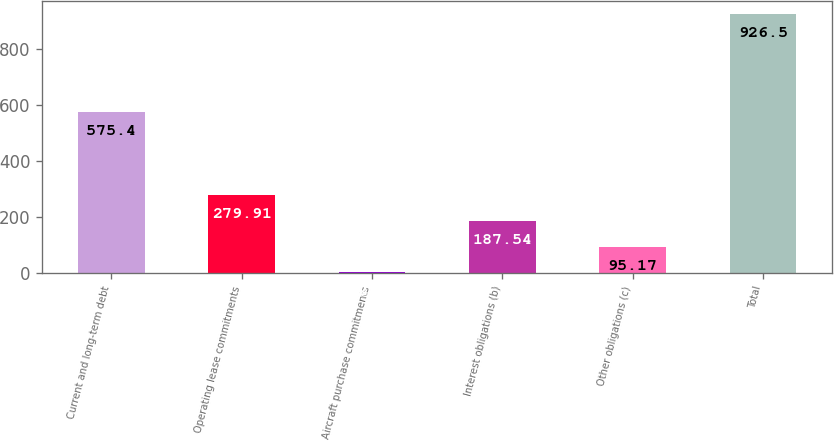Convert chart. <chart><loc_0><loc_0><loc_500><loc_500><bar_chart><fcel>Current and long-term debt<fcel>Operating lease commitments<fcel>Aircraft purchase commitments<fcel>Interest obligations (b)<fcel>Other obligations (c)<fcel>Total<nl><fcel>575.4<fcel>279.91<fcel>2.8<fcel>187.54<fcel>95.17<fcel>926.5<nl></chart> 